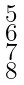<formula> <loc_0><loc_0><loc_500><loc_500>\begin{smallmatrix} 5 \\ 6 \\ 7 \\ 8 \end{smallmatrix}</formula> 